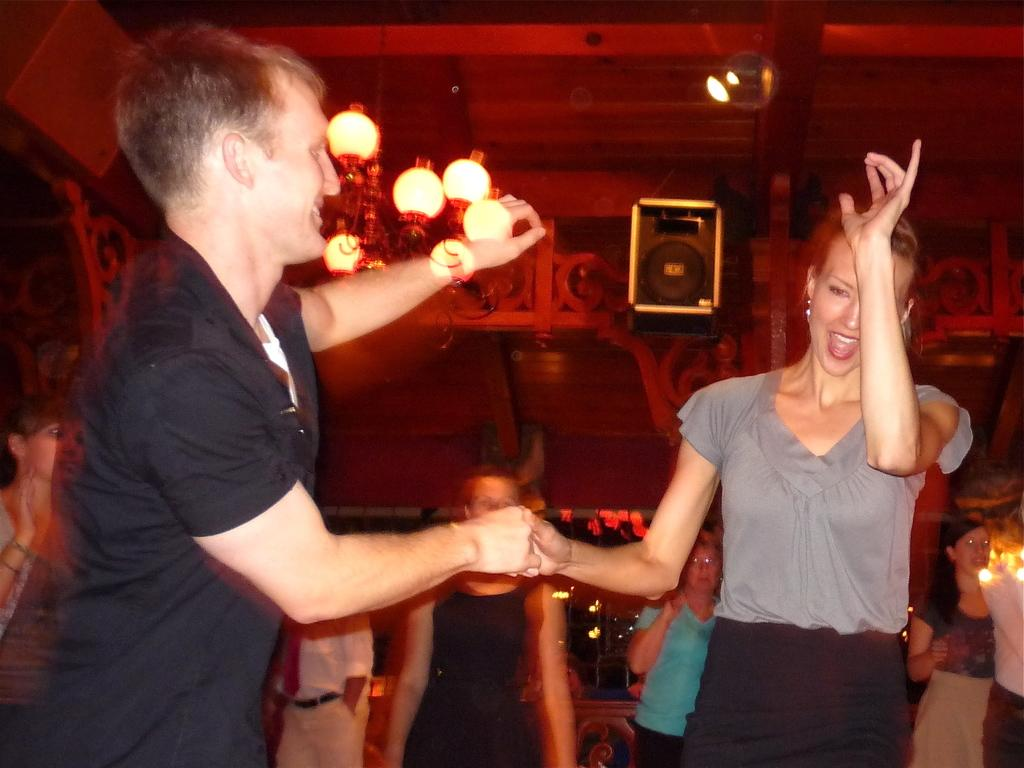What can be seen in the image involving people? There are people standing in the image. What can be seen in the image that provides illumination? There are lights visible in the image. What object in the image is used for amplifying sound? There is a speaker in the image. How would you describe the clarity of the image? The image is slightly blurry. How many chairs can be seen in the image? There are no chairs present in the image. What type of crack is visible on the speaker in the image? There is no crack visible on the speaker in the image. 